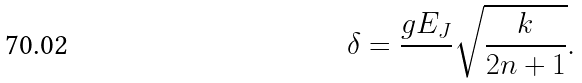<formula> <loc_0><loc_0><loc_500><loc_500>\delta = \frac { g E _ { J } } { } \sqrt { \frac { k } { 2 n + 1 } } .</formula> 